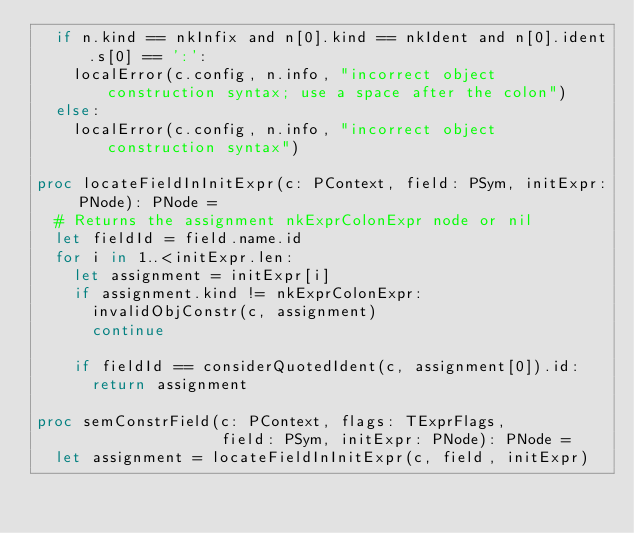<code> <loc_0><loc_0><loc_500><loc_500><_Nim_>  if n.kind == nkInfix and n[0].kind == nkIdent and n[0].ident.s[0] == ':':
    localError(c.config, n.info, "incorrect object construction syntax; use a space after the colon")
  else:
    localError(c.config, n.info, "incorrect object construction syntax")

proc locateFieldInInitExpr(c: PContext, field: PSym, initExpr: PNode): PNode =
  # Returns the assignment nkExprColonExpr node or nil
  let fieldId = field.name.id
  for i in 1..<initExpr.len:
    let assignment = initExpr[i]
    if assignment.kind != nkExprColonExpr:
      invalidObjConstr(c, assignment)
      continue

    if fieldId == considerQuotedIdent(c, assignment[0]).id:
      return assignment

proc semConstrField(c: PContext, flags: TExprFlags,
                    field: PSym, initExpr: PNode): PNode =
  let assignment = locateFieldInInitExpr(c, field, initExpr)</code> 